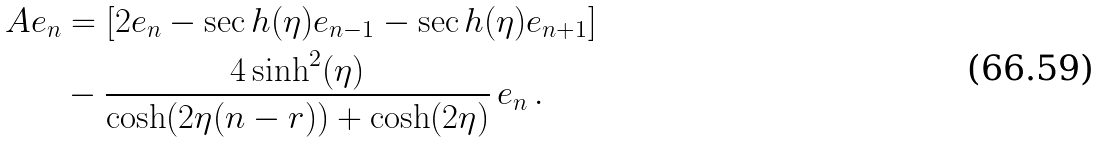Convert formula to latex. <formula><loc_0><loc_0><loc_500><loc_500>A e _ { n } & = [ 2 e _ { n } - \sec h ( \eta ) e _ { n - 1 } - \sec h ( \eta ) e _ { n + 1 } ] \\ & - \frac { 4 \sinh ^ { 2 } ( \eta ) } { \cosh ( 2 \eta ( n - r ) ) + \cosh ( 2 \eta ) } \, e _ { n } \, .</formula> 